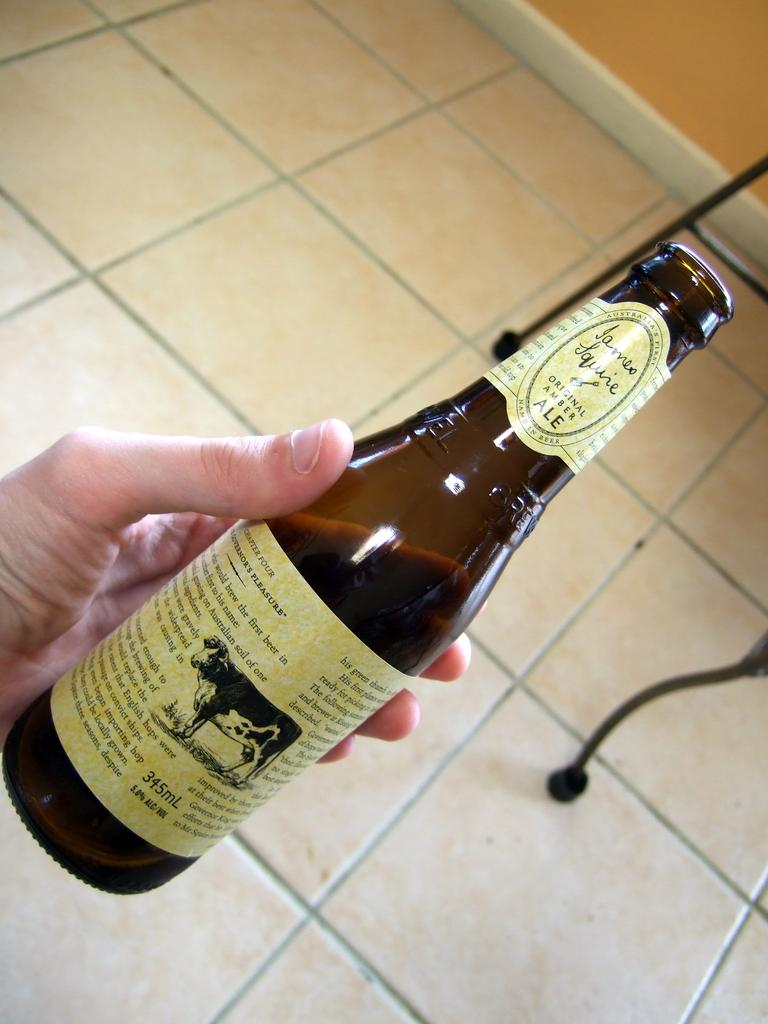What is being held by the hand in the image? The hand is holding a bottle. What is the background of the image composed of? The background of the image includes a floor and a wall. How many chickens can be seen in the image? There are no chickens present in the image. What type of space is depicted in the image? The image does not depict any space; it shows a hand holding a bottle against a background of a floor and a wall. 